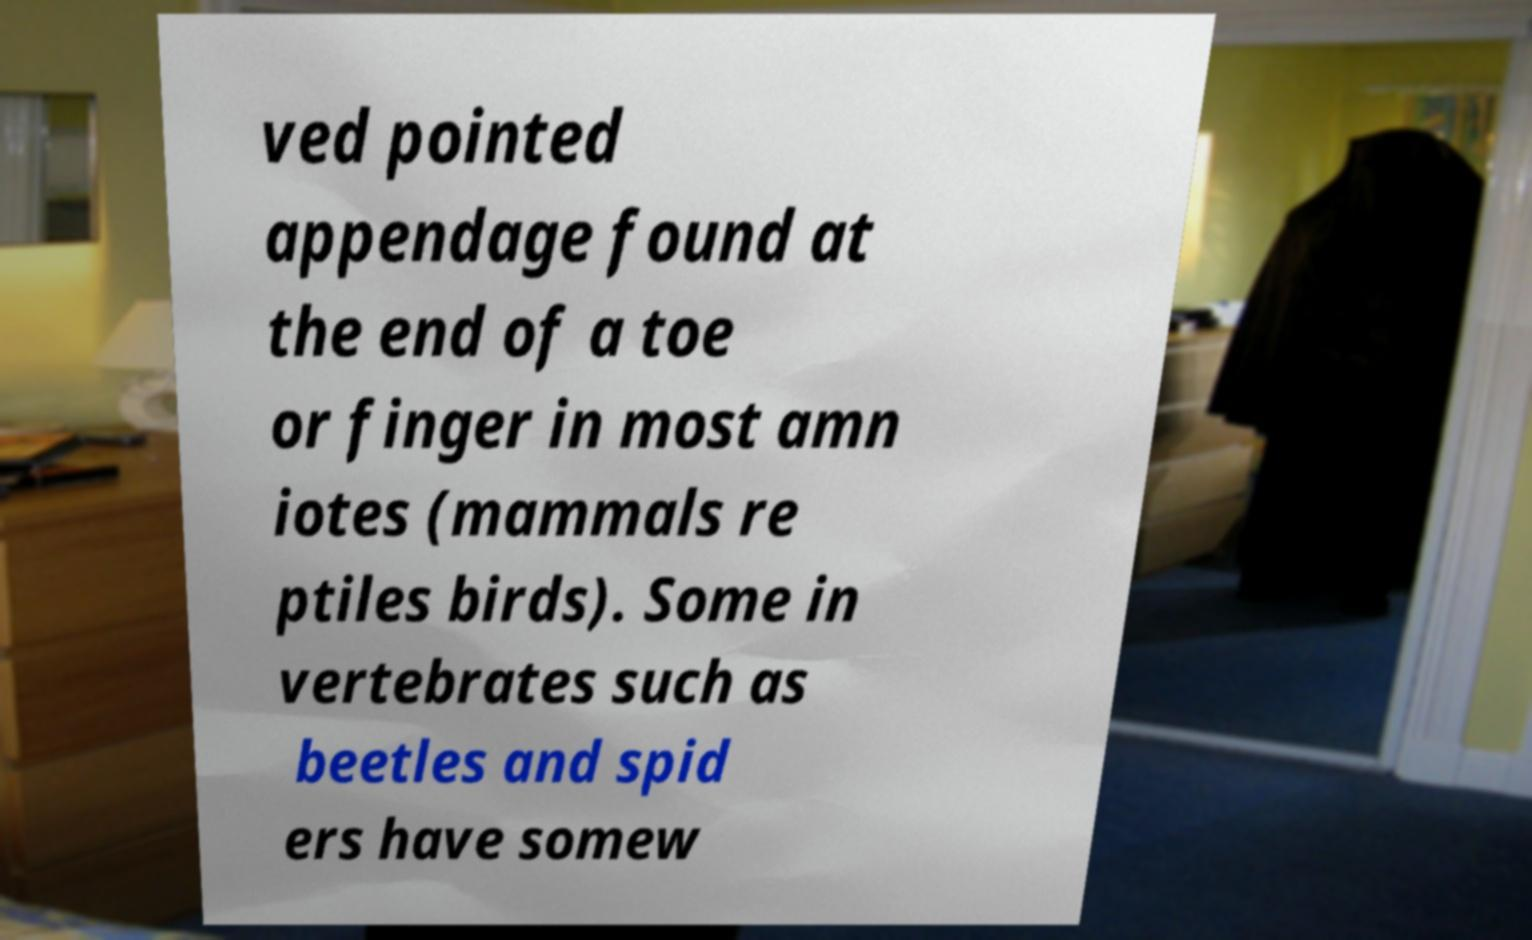Could you extract and type out the text from this image? ved pointed appendage found at the end of a toe or finger in most amn iotes (mammals re ptiles birds). Some in vertebrates such as beetles and spid ers have somew 